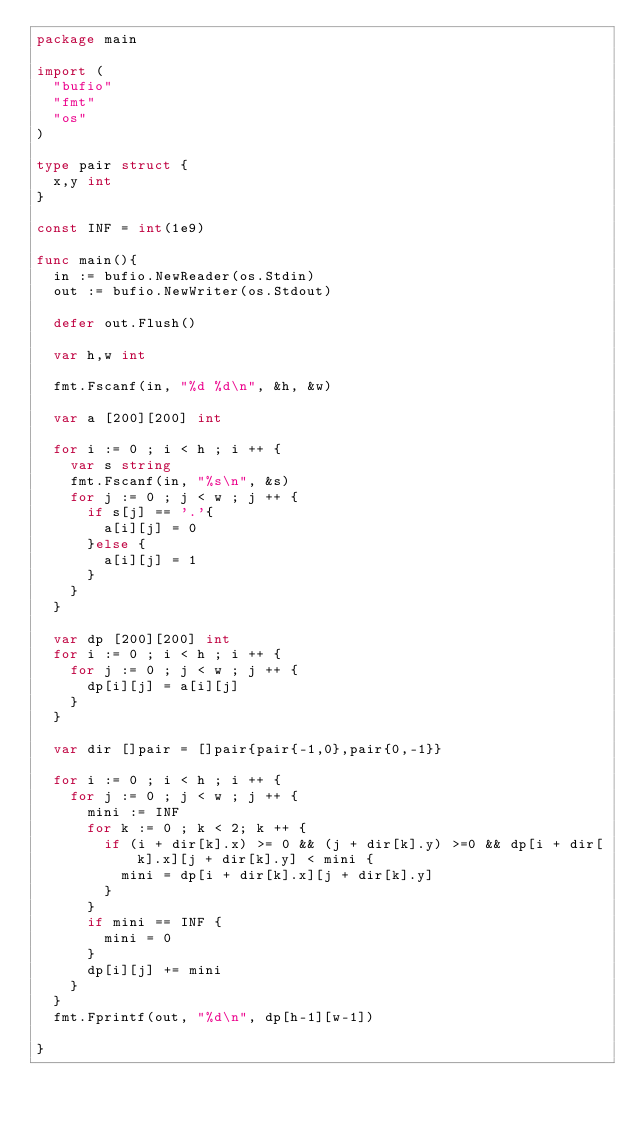<code> <loc_0><loc_0><loc_500><loc_500><_Go_>package main

import (
	"bufio"
	"fmt"
	"os"
)

type pair struct {
	x,y int
}

const INF = int(1e9)

func main(){
	in := bufio.NewReader(os.Stdin)
	out := bufio.NewWriter(os.Stdout)

	defer out.Flush()

	var h,w int

	fmt.Fscanf(in, "%d %d\n", &h, &w)

	var a [200][200] int

	for i := 0 ; i < h ; i ++ {
		var s string
		fmt.Fscanf(in, "%s\n", &s)
		for j := 0 ; j < w ; j ++ {
			if s[j] == '.'{
				a[i][j] = 0
			}else {
				a[i][j] = 1
			}
		}
	}

	var dp [200][200] int
	for i := 0 ; i < h ; i ++ {
		for j := 0 ; j < w ; j ++ {
			dp[i][j] = a[i][j]
		}
	}

	var dir []pair = []pair{pair{-1,0},pair{0,-1}}

	for i := 0 ; i < h ; i ++ {
		for j := 0 ; j < w ; j ++ {
			mini := INF
			for k := 0 ; k < 2; k ++ {
				if (i + dir[k].x) >= 0 && (j + dir[k].y) >=0 && dp[i + dir[k].x][j + dir[k].y] < mini {
					mini = dp[i + dir[k].x][j + dir[k].y]
				}
			}
			if mini == INF {
				mini = 0
			}
			dp[i][j] += mini
		}
	}
	fmt.Fprintf(out, "%d\n", dp[h-1][w-1])

}
</code> 